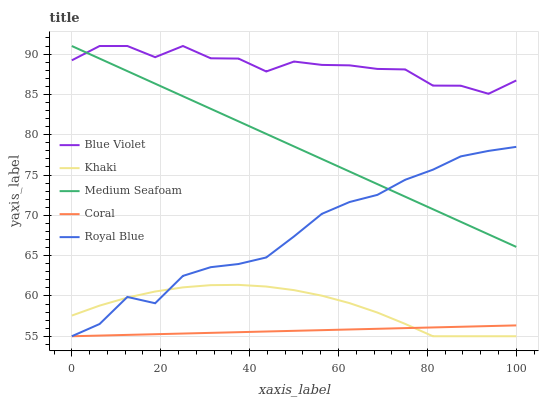Does Coral have the minimum area under the curve?
Answer yes or no. Yes. Does Blue Violet have the maximum area under the curve?
Answer yes or no. Yes. Does Khaki have the minimum area under the curve?
Answer yes or no. No. Does Khaki have the maximum area under the curve?
Answer yes or no. No. Is Coral the smoothest?
Answer yes or no. Yes. Is Blue Violet the roughest?
Answer yes or no. Yes. Is Khaki the smoothest?
Answer yes or no. No. Is Khaki the roughest?
Answer yes or no. No. Does Royal Blue have the lowest value?
Answer yes or no. Yes. Does Medium Seafoam have the lowest value?
Answer yes or no. No. Does Blue Violet have the highest value?
Answer yes or no. Yes. Does Khaki have the highest value?
Answer yes or no. No. Is Coral less than Blue Violet?
Answer yes or no. Yes. Is Blue Violet greater than Khaki?
Answer yes or no. Yes. Does Coral intersect Khaki?
Answer yes or no. Yes. Is Coral less than Khaki?
Answer yes or no. No. Is Coral greater than Khaki?
Answer yes or no. No. Does Coral intersect Blue Violet?
Answer yes or no. No. 